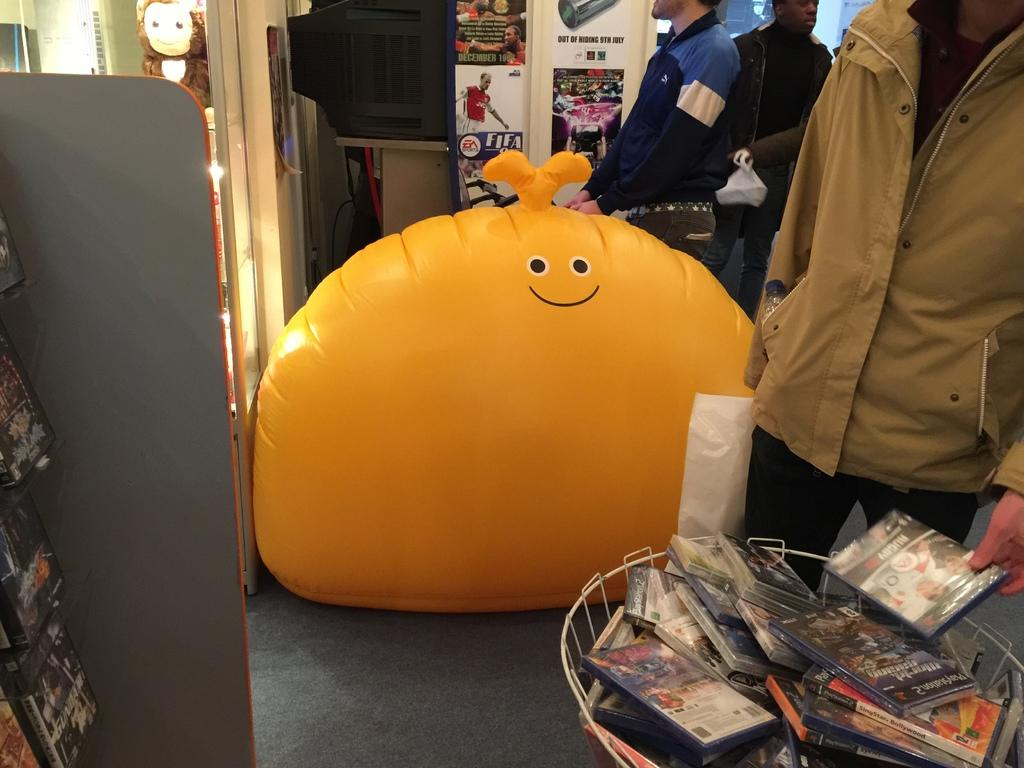Provide a one-sentence caption for the provided image. Giant orange bean balloon in front of a FIFA poster. 